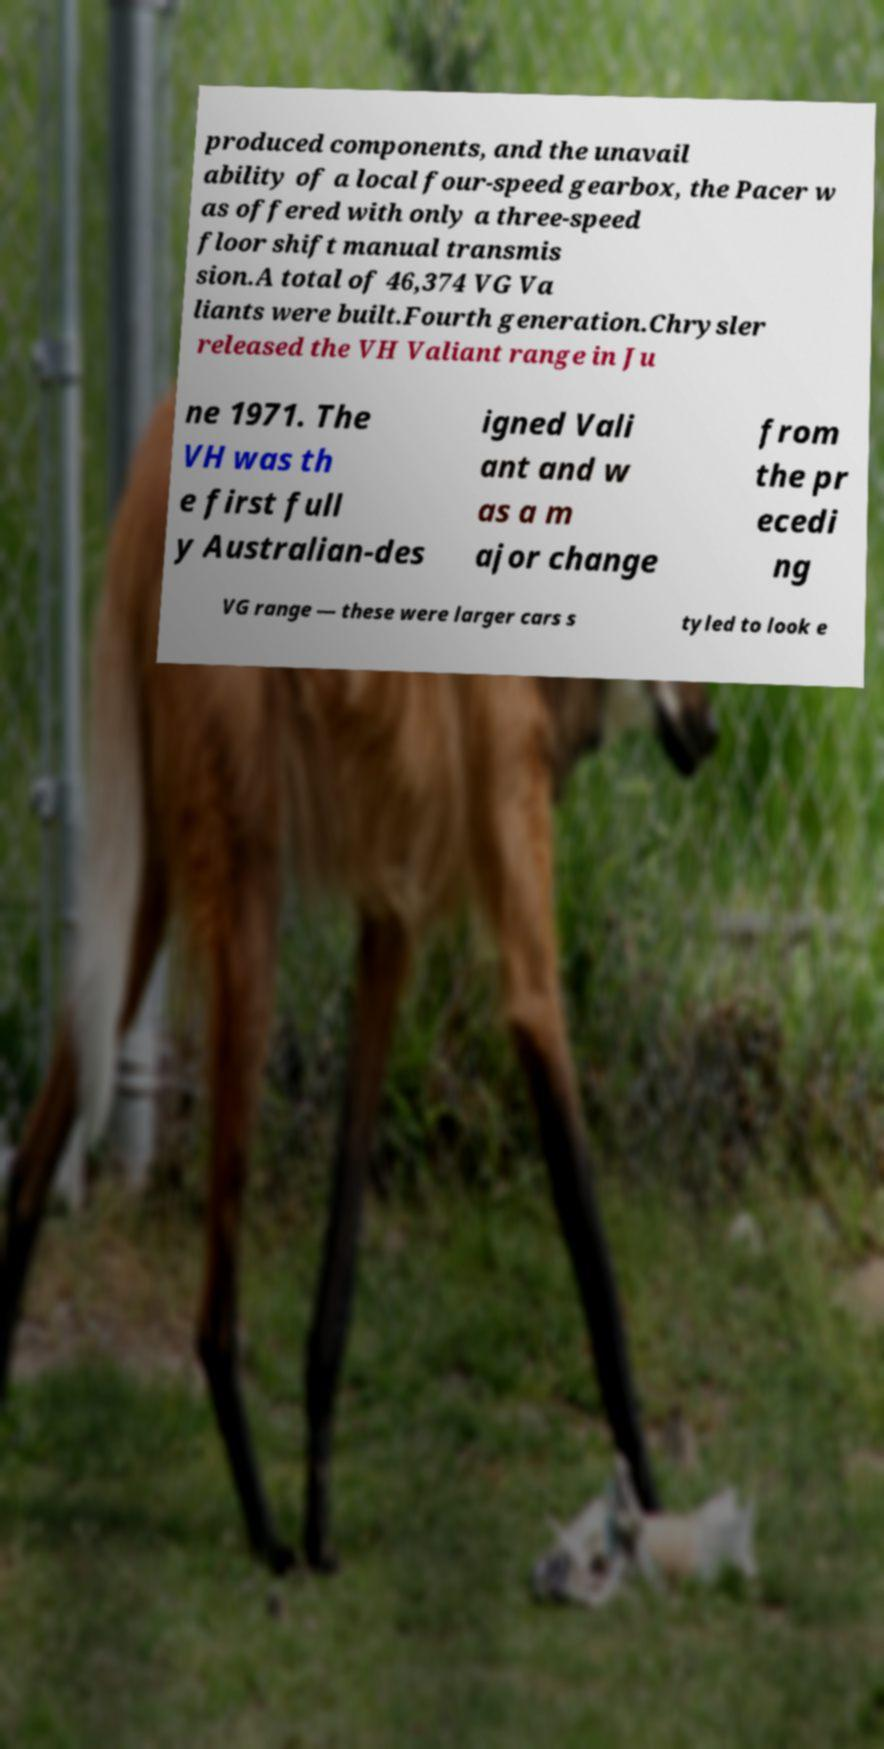For documentation purposes, I need the text within this image transcribed. Could you provide that? produced components, and the unavail ability of a local four-speed gearbox, the Pacer w as offered with only a three-speed floor shift manual transmis sion.A total of 46,374 VG Va liants were built.Fourth generation.Chrysler released the VH Valiant range in Ju ne 1971. The VH was th e first full y Australian-des igned Vali ant and w as a m ajor change from the pr ecedi ng VG range — these were larger cars s tyled to look e 